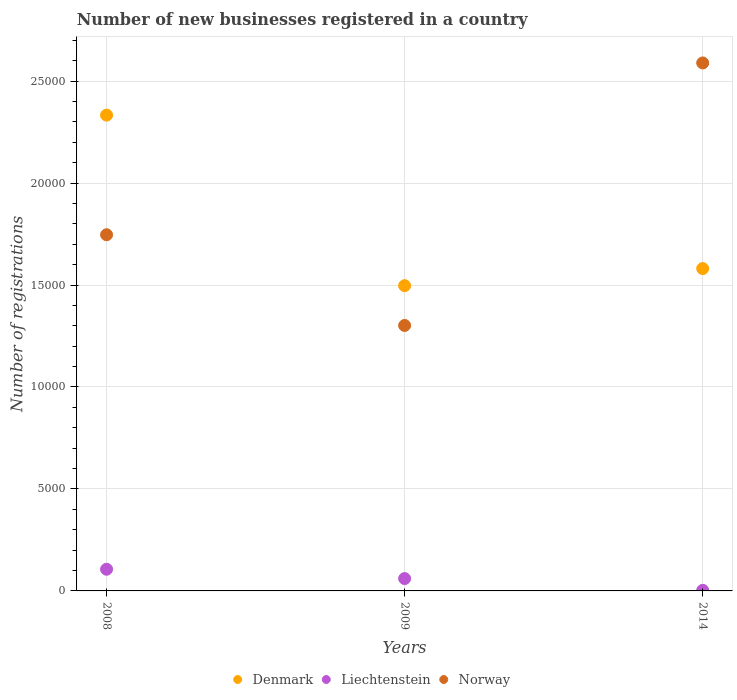Is the number of dotlines equal to the number of legend labels?
Offer a very short reply. Yes. What is the number of new businesses registered in Liechtenstein in 2008?
Give a very brief answer. 1063. Across all years, what is the maximum number of new businesses registered in Norway?
Provide a succinct answer. 2.59e+04. Across all years, what is the minimum number of new businesses registered in Denmark?
Make the answer very short. 1.50e+04. What is the total number of new businesses registered in Norway in the graph?
Keep it short and to the point. 5.64e+04. What is the difference between the number of new businesses registered in Denmark in 2008 and that in 2009?
Ensure brevity in your answer.  8362. What is the difference between the number of new businesses registered in Liechtenstein in 2014 and the number of new businesses registered in Norway in 2009?
Make the answer very short. -1.30e+04. What is the average number of new businesses registered in Norway per year?
Keep it short and to the point. 1.88e+04. In the year 2009, what is the difference between the number of new businesses registered in Liechtenstein and number of new businesses registered in Norway?
Offer a terse response. -1.24e+04. What is the ratio of the number of new businesses registered in Denmark in 2008 to that in 2009?
Offer a terse response. 1.56. What is the difference between the highest and the second highest number of new businesses registered in Denmark?
Offer a terse response. 7523. What is the difference between the highest and the lowest number of new businesses registered in Liechtenstein?
Keep it short and to the point. 1034. Is it the case that in every year, the sum of the number of new businesses registered in Denmark and number of new businesses registered in Norway  is greater than the number of new businesses registered in Liechtenstein?
Your response must be concise. Yes. Does the number of new businesses registered in Liechtenstein monotonically increase over the years?
Give a very brief answer. No. Is the number of new businesses registered in Norway strictly less than the number of new businesses registered in Liechtenstein over the years?
Your answer should be compact. No. How many years are there in the graph?
Offer a very short reply. 3. What is the difference between two consecutive major ticks on the Y-axis?
Provide a succinct answer. 5000. Are the values on the major ticks of Y-axis written in scientific E-notation?
Ensure brevity in your answer.  No. Does the graph contain grids?
Offer a terse response. Yes. How many legend labels are there?
Offer a terse response. 3. What is the title of the graph?
Your answer should be very brief. Number of new businesses registered in a country. Does "Finland" appear as one of the legend labels in the graph?
Make the answer very short. No. What is the label or title of the Y-axis?
Ensure brevity in your answer.  Number of registrations. What is the Number of registrations in Denmark in 2008?
Offer a very short reply. 2.33e+04. What is the Number of registrations in Liechtenstein in 2008?
Provide a succinct answer. 1063. What is the Number of registrations in Norway in 2008?
Your answer should be compact. 1.75e+04. What is the Number of registrations in Denmark in 2009?
Give a very brief answer. 1.50e+04. What is the Number of registrations of Liechtenstein in 2009?
Ensure brevity in your answer.  606. What is the Number of registrations in Norway in 2009?
Provide a short and direct response. 1.30e+04. What is the Number of registrations of Denmark in 2014?
Give a very brief answer. 1.58e+04. What is the Number of registrations in Norway in 2014?
Ensure brevity in your answer.  2.59e+04. Across all years, what is the maximum Number of registrations in Denmark?
Ensure brevity in your answer.  2.33e+04. Across all years, what is the maximum Number of registrations of Liechtenstein?
Make the answer very short. 1063. Across all years, what is the maximum Number of registrations in Norway?
Provide a short and direct response. 2.59e+04. Across all years, what is the minimum Number of registrations of Denmark?
Your answer should be very brief. 1.50e+04. Across all years, what is the minimum Number of registrations in Liechtenstein?
Offer a terse response. 29. Across all years, what is the minimum Number of registrations in Norway?
Offer a terse response. 1.30e+04. What is the total Number of registrations of Denmark in the graph?
Provide a short and direct response. 5.41e+04. What is the total Number of registrations in Liechtenstein in the graph?
Provide a succinct answer. 1698. What is the total Number of registrations of Norway in the graph?
Your answer should be compact. 5.64e+04. What is the difference between the Number of registrations of Denmark in 2008 and that in 2009?
Your answer should be very brief. 8362. What is the difference between the Number of registrations of Liechtenstein in 2008 and that in 2009?
Your answer should be compact. 457. What is the difference between the Number of registrations of Norway in 2008 and that in 2009?
Keep it short and to the point. 4449. What is the difference between the Number of registrations of Denmark in 2008 and that in 2014?
Offer a very short reply. 7523. What is the difference between the Number of registrations of Liechtenstein in 2008 and that in 2014?
Provide a short and direct response. 1034. What is the difference between the Number of registrations in Norway in 2008 and that in 2014?
Your response must be concise. -8423. What is the difference between the Number of registrations in Denmark in 2009 and that in 2014?
Your answer should be compact. -839. What is the difference between the Number of registrations of Liechtenstein in 2009 and that in 2014?
Make the answer very short. 577. What is the difference between the Number of registrations of Norway in 2009 and that in 2014?
Offer a terse response. -1.29e+04. What is the difference between the Number of registrations of Denmark in 2008 and the Number of registrations of Liechtenstein in 2009?
Provide a succinct answer. 2.27e+04. What is the difference between the Number of registrations in Denmark in 2008 and the Number of registrations in Norway in 2009?
Offer a terse response. 1.03e+04. What is the difference between the Number of registrations of Liechtenstein in 2008 and the Number of registrations of Norway in 2009?
Make the answer very short. -1.20e+04. What is the difference between the Number of registrations of Denmark in 2008 and the Number of registrations of Liechtenstein in 2014?
Provide a short and direct response. 2.33e+04. What is the difference between the Number of registrations of Denmark in 2008 and the Number of registrations of Norway in 2014?
Keep it short and to the point. -2559. What is the difference between the Number of registrations of Liechtenstein in 2008 and the Number of registrations of Norway in 2014?
Give a very brief answer. -2.48e+04. What is the difference between the Number of registrations of Denmark in 2009 and the Number of registrations of Liechtenstein in 2014?
Keep it short and to the point. 1.49e+04. What is the difference between the Number of registrations of Denmark in 2009 and the Number of registrations of Norway in 2014?
Provide a short and direct response. -1.09e+04. What is the difference between the Number of registrations of Liechtenstein in 2009 and the Number of registrations of Norway in 2014?
Give a very brief answer. -2.53e+04. What is the average Number of registrations in Denmark per year?
Keep it short and to the point. 1.80e+04. What is the average Number of registrations of Liechtenstein per year?
Give a very brief answer. 566. What is the average Number of registrations of Norway per year?
Your response must be concise. 1.88e+04. In the year 2008, what is the difference between the Number of registrations of Denmark and Number of registrations of Liechtenstein?
Your answer should be very brief. 2.23e+04. In the year 2008, what is the difference between the Number of registrations of Denmark and Number of registrations of Norway?
Your answer should be compact. 5864. In the year 2008, what is the difference between the Number of registrations in Liechtenstein and Number of registrations in Norway?
Ensure brevity in your answer.  -1.64e+04. In the year 2009, what is the difference between the Number of registrations of Denmark and Number of registrations of Liechtenstein?
Offer a very short reply. 1.44e+04. In the year 2009, what is the difference between the Number of registrations in Denmark and Number of registrations in Norway?
Make the answer very short. 1951. In the year 2009, what is the difference between the Number of registrations in Liechtenstein and Number of registrations in Norway?
Your answer should be compact. -1.24e+04. In the year 2014, what is the difference between the Number of registrations of Denmark and Number of registrations of Liechtenstein?
Provide a succinct answer. 1.58e+04. In the year 2014, what is the difference between the Number of registrations in Denmark and Number of registrations in Norway?
Provide a succinct answer. -1.01e+04. In the year 2014, what is the difference between the Number of registrations in Liechtenstein and Number of registrations in Norway?
Offer a very short reply. -2.59e+04. What is the ratio of the Number of registrations in Denmark in 2008 to that in 2009?
Provide a short and direct response. 1.56. What is the ratio of the Number of registrations of Liechtenstein in 2008 to that in 2009?
Offer a very short reply. 1.75. What is the ratio of the Number of registrations of Norway in 2008 to that in 2009?
Give a very brief answer. 1.34. What is the ratio of the Number of registrations of Denmark in 2008 to that in 2014?
Provide a succinct answer. 1.48. What is the ratio of the Number of registrations of Liechtenstein in 2008 to that in 2014?
Your answer should be very brief. 36.66. What is the ratio of the Number of registrations in Norway in 2008 to that in 2014?
Ensure brevity in your answer.  0.67. What is the ratio of the Number of registrations in Denmark in 2009 to that in 2014?
Offer a terse response. 0.95. What is the ratio of the Number of registrations of Liechtenstein in 2009 to that in 2014?
Your answer should be compact. 20.9. What is the ratio of the Number of registrations of Norway in 2009 to that in 2014?
Offer a very short reply. 0.5. What is the difference between the highest and the second highest Number of registrations of Denmark?
Give a very brief answer. 7523. What is the difference between the highest and the second highest Number of registrations in Liechtenstein?
Your answer should be very brief. 457. What is the difference between the highest and the second highest Number of registrations of Norway?
Provide a succinct answer. 8423. What is the difference between the highest and the lowest Number of registrations of Denmark?
Provide a short and direct response. 8362. What is the difference between the highest and the lowest Number of registrations of Liechtenstein?
Ensure brevity in your answer.  1034. What is the difference between the highest and the lowest Number of registrations in Norway?
Your answer should be compact. 1.29e+04. 